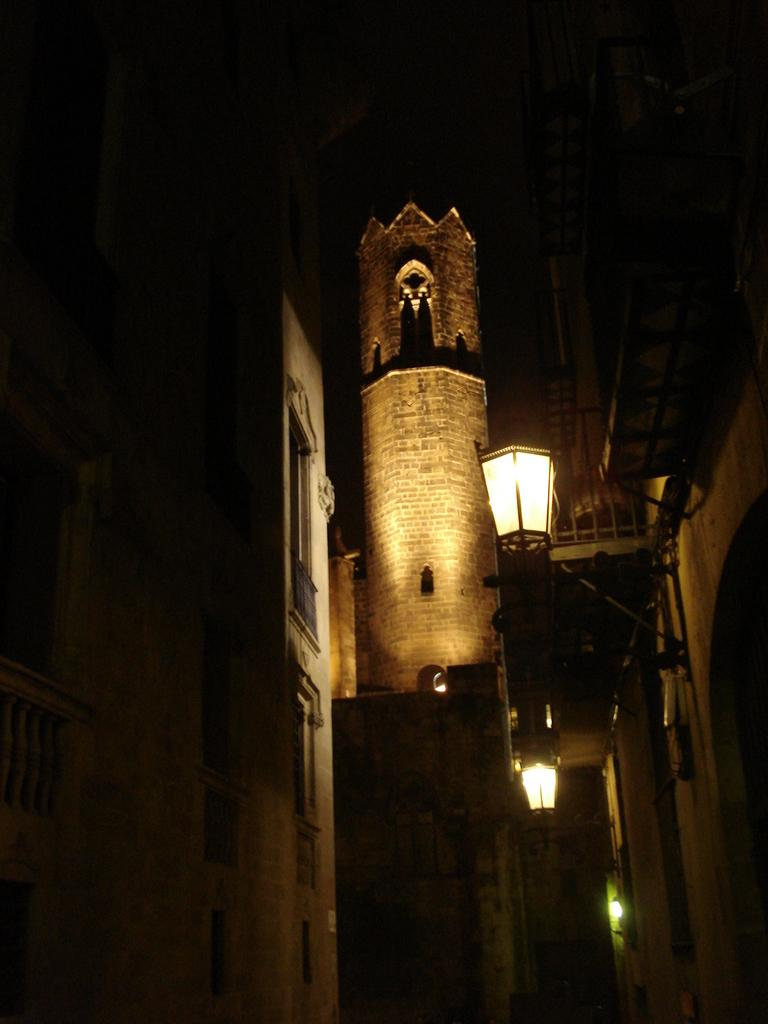What type of structure is present in the image? There is a fort in the image. What other structures can be seen in the image? There are buildings in the image. What can be used to illuminate the area in the image? There are lights in the image. What material is used for some of the structures in the image? Metal rods are visible in the image. Can you see a van in the image? There is no van present in the image. Is the fort located in space in the image? The image does not depict the fort in space; it is located on the ground. 